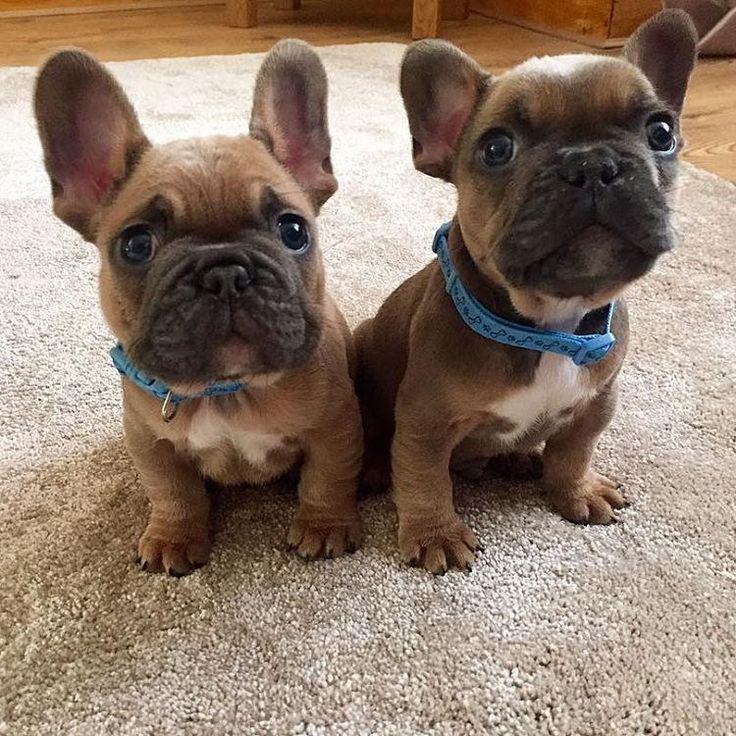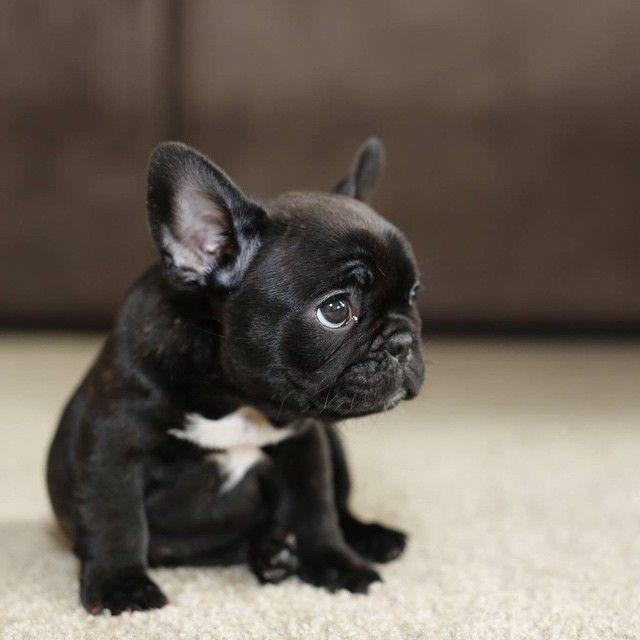The first image is the image on the left, the second image is the image on the right. Evaluate the accuracy of this statement regarding the images: "An image shows exactly two real puppies.". Is it true? Answer yes or no. Yes. The first image is the image on the left, the second image is the image on the right. Considering the images on both sides, is "One of the images shows exactly two dogs." valid? Answer yes or no. Yes. 